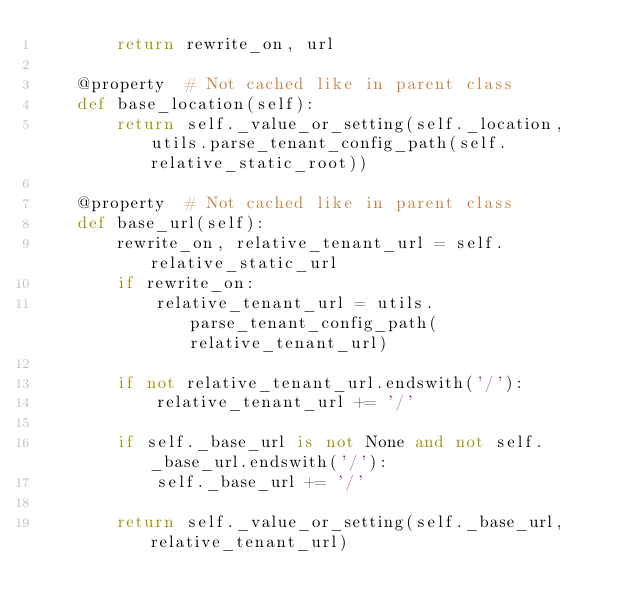Convert code to text. <code><loc_0><loc_0><loc_500><loc_500><_Python_>        return rewrite_on, url

    @property  # Not cached like in parent class
    def base_location(self):
        return self._value_or_setting(self._location, utils.parse_tenant_config_path(self.relative_static_root))

    @property  # Not cached like in parent class
    def base_url(self):
        rewrite_on, relative_tenant_url = self.relative_static_url
        if rewrite_on:
            relative_tenant_url = utils.parse_tenant_config_path(relative_tenant_url)

        if not relative_tenant_url.endswith('/'):
            relative_tenant_url += '/'

        if self._base_url is not None and not self._base_url.endswith('/'):
            self._base_url += '/'

        return self._value_or_setting(self._base_url, relative_tenant_url)
</code> 